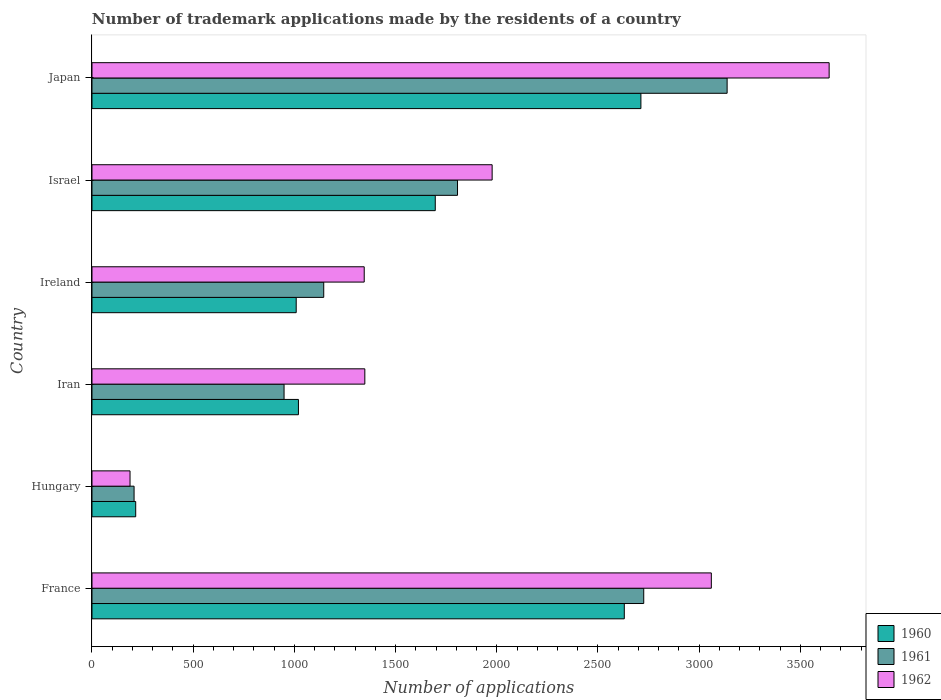Are the number of bars per tick equal to the number of legend labels?
Offer a very short reply. Yes. What is the number of trademark applications made by the residents in 1962 in Japan?
Give a very brief answer. 3642. Across all countries, what is the maximum number of trademark applications made by the residents in 1962?
Provide a succinct answer. 3642. Across all countries, what is the minimum number of trademark applications made by the residents in 1962?
Your answer should be compact. 188. In which country was the number of trademark applications made by the residents in 1960 minimum?
Offer a very short reply. Hungary. What is the total number of trademark applications made by the residents in 1961 in the graph?
Keep it short and to the point. 9972. What is the difference between the number of trademark applications made by the residents in 1960 in Hungary and that in Iran?
Offer a very short reply. -804. What is the difference between the number of trademark applications made by the residents in 1962 in Israel and the number of trademark applications made by the residents in 1961 in Ireland?
Your response must be concise. 832. What is the average number of trademark applications made by the residents in 1960 per country?
Your response must be concise. 1547.17. What is the ratio of the number of trademark applications made by the residents in 1962 in Iran to that in Israel?
Provide a succinct answer. 0.68. Is the number of trademark applications made by the residents in 1961 in France less than that in Japan?
Your answer should be compact. Yes. Is the difference between the number of trademark applications made by the residents in 1962 in Iran and Israel greater than the difference between the number of trademark applications made by the residents in 1961 in Iran and Israel?
Give a very brief answer. Yes. What is the difference between the highest and the second highest number of trademark applications made by the residents in 1961?
Ensure brevity in your answer.  412. What is the difference between the highest and the lowest number of trademark applications made by the residents in 1960?
Your response must be concise. 2496. Is the sum of the number of trademark applications made by the residents in 1962 in Israel and Japan greater than the maximum number of trademark applications made by the residents in 1961 across all countries?
Give a very brief answer. Yes. Is it the case that in every country, the sum of the number of trademark applications made by the residents in 1962 and number of trademark applications made by the residents in 1961 is greater than the number of trademark applications made by the residents in 1960?
Keep it short and to the point. Yes. How many bars are there?
Offer a terse response. 18. Are all the bars in the graph horizontal?
Offer a very short reply. Yes. Does the graph contain grids?
Offer a terse response. No. How many legend labels are there?
Make the answer very short. 3. How are the legend labels stacked?
Your answer should be compact. Vertical. What is the title of the graph?
Offer a terse response. Number of trademark applications made by the residents of a country. Does "1994" appear as one of the legend labels in the graph?
Offer a terse response. No. What is the label or title of the X-axis?
Give a very brief answer. Number of applications. What is the Number of applications in 1960 in France?
Your answer should be very brief. 2630. What is the Number of applications in 1961 in France?
Offer a terse response. 2726. What is the Number of applications of 1962 in France?
Your answer should be very brief. 3060. What is the Number of applications in 1960 in Hungary?
Provide a short and direct response. 216. What is the Number of applications of 1961 in Hungary?
Provide a short and direct response. 208. What is the Number of applications in 1962 in Hungary?
Offer a terse response. 188. What is the Number of applications in 1960 in Iran?
Keep it short and to the point. 1020. What is the Number of applications of 1961 in Iran?
Make the answer very short. 949. What is the Number of applications of 1962 in Iran?
Your answer should be compact. 1348. What is the Number of applications of 1960 in Ireland?
Provide a succinct answer. 1009. What is the Number of applications in 1961 in Ireland?
Give a very brief answer. 1145. What is the Number of applications of 1962 in Ireland?
Provide a succinct answer. 1345. What is the Number of applications of 1960 in Israel?
Your answer should be very brief. 1696. What is the Number of applications in 1961 in Israel?
Your answer should be compact. 1806. What is the Number of applications in 1962 in Israel?
Keep it short and to the point. 1977. What is the Number of applications in 1960 in Japan?
Your answer should be very brief. 2712. What is the Number of applications in 1961 in Japan?
Provide a succinct answer. 3138. What is the Number of applications in 1962 in Japan?
Make the answer very short. 3642. Across all countries, what is the maximum Number of applications of 1960?
Your response must be concise. 2712. Across all countries, what is the maximum Number of applications of 1961?
Provide a short and direct response. 3138. Across all countries, what is the maximum Number of applications in 1962?
Keep it short and to the point. 3642. Across all countries, what is the minimum Number of applications in 1960?
Make the answer very short. 216. Across all countries, what is the minimum Number of applications of 1961?
Keep it short and to the point. 208. Across all countries, what is the minimum Number of applications in 1962?
Make the answer very short. 188. What is the total Number of applications of 1960 in the graph?
Your response must be concise. 9283. What is the total Number of applications in 1961 in the graph?
Offer a terse response. 9972. What is the total Number of applications of 1962 in the graph?
Your response must be concise. 1.16e+04. What is the difference between the Number of applications in 1960 in France and that in Hungary?
Provide a short and direct response. 2414. What is the difference between the Number of applications in 1961 in France and that in Hungary?
Your answer should be very brief. 2518. What is the difference between the Number of applications in 1962 in France and that in Hungary?
Your answer should be very brief. 2872. What is the difference between the Number of applications of 1960 in France and that in Iran?
Your answer should be very brief. 1610. What is the difference between the Number of applications in 1961 in France and that in Iran?
Ensure brevity in your answer.  1777. What is the difference between the Number of applications of 1962 in France and that in Iran?
Your answer should be very brief. 1712. What is the difference between the Number of applications of 1960 in France and that in Ireland?
Provide a succinct answer. 1621. What is the difference between the Number of applications of 1961 in France and that in Ireland?
Offer a terse response. 1581. What is the difference between the Number of applications in 1962 in France and that in Ireland?
Your answer should be compact. 1715. What is the difference between the Number of applications of 1960 in France and that in Israel?
Ensure brevity in your answer.  934. What is the difference between the Number of applications of 1961 in France and that in Israel?
Keep it short and to the point. 920. What is the difference between the Number of applications of 1962 in France and that in Israel?
Make the answer very short. 1083. What is the difference between the Number of applications of 1960 in France and that in Japan?
Your response must be concise. -82. What is the difference between the Number of applications in 1961 in France and that in Japan?
Your response must be concise. -412. What is the difference between the Number of applications in 1962 in France and that in Japan?
Ensure brevity in your answer.  -582. What is the difference between the Number of applications of 1960 in Hungary and that in Iran?
Your answer should be compact. -804. What is the difference between the Number of applications of 1961 in Hungary and that in Iran?
Give a very brief answer. -741. What is the difference between the Number of applications in 1962 in Hungary and that in Iran?
Make the answer very short. -1160. What is the difference between the Number of applications in 1960 in Hungary and that in Ireland?
Offer a terse response. -793. What is the difference between the Number of applications in 1961 in Hungary and that in Ireland?
Your answer should be compact. -937. What is the difference between the Number of applications of 1962 in Hungary and that in Ireland?
Ensure brevity in your answer.  -1157. What is the difference between the Number of applications of 1960 in Hungary and that in Israel?
Make the answer very short. -1480. What is the difference between the Number of applications in 1961 in Hungary and that in Israel?
Keep it short and to the point. -1598. What is the difference between the Number of applications of 1962 in Hungary and that in Israel?
Keep it short and to the point. -1789. What is the difference between the Number of applications in 1960 in Hungary and that in Japan?
Ensure brevity in your answer.  -2496. What is the difference between the Number of applications of 1961 in Hungary and that in Japan?
Offer a very short reply. -2930. What is the difference between the Number of applications of 1962 in Hungary and that in Japan?
Provide a short and direct response. -3454. What is the difference between the Number of applications of 1961 in Iran and that in Ireland?
Provide a succinct answer. -196. What is the difference between the Number of applications in 1960 in Iran and that in Israel?
Ensure brevity in your answer.  -676. What is the difference between the Number of applications in 1961 in Iran and that in Israel?
Give a very brief answer. -857. What is the difference between the Number of applications of 1962 in Iran and that in Israel?
Offer a terse response. -629. What is the difference between the Number of applications in 1960 in Iran and that in Japan?
Give a very brief answer. -1692. What is the difference between the Number of applications in 1961 in Iran and that in Japan?
Offer a very short reply. -2189. What is the difference between the Number of applications in 1962 in Iran and that in Japan?
Keep it short and to the point. -2294. What is the difference between the Number of applications of 1960 in Ireland and that in Israel?
Give a very brief answer. -687. What is the difference between the Number of applications in 1961 in Ireland and that in Israel?
Keep it short and to the point. -661. What is the difference between the Number of applications in 1962 in Ireland and that in Israel?
Provide a short and direct response. -632. What is the difference between the Number of applications of 1960 in Ireland and that in Japan?
Provide a succinct answer. -1703. What is the difference between the Number of applications of 1961 in Ireland and that in Japan?
Offer a terse response. -1993. What is the difference between the Number of applications in 1962 in Ireland and that in Japan?
Offer a very short reply. -2297. What is the difference between the Number of applications in 1960 in Israel and that in Japan?
Your answer should be very brief. -1016. What is the difference between the Number of applications in 1961 in Israel and that in Japan?
Your answer should be very brief. -1332. What is the difference between the Number of applications in 1962 in Israel and that in Japan?
Make the answer very short. -1665. What is the difference between the Number of applications of 1960 in France and the Number of applications of 1961 in Hungary?
Keep it short and to the point. 2422. What is the difference between the Number of applications of 1960 in France and the Number of applications of 1962 in Hungary?
Your answer should be compact. 2442. What is the difference between the Number of applications of 1961 in France and the Number of applications of 1962 in Hungary?
Keep it short and to the point. 2538. What is the difference between the Number of applications in 1960 in France and the Number of applications in 1961 in Iran?
Provide a succinct answer. 1681. What is the difference between the Number of applications of 1960 in France and the Number of applications of 1962 in Iran?
Offer a very short reply. 1282. What is the difference between the Number of applications of 1961 in France and the Number of applications of 1962 in Iran?
Keep it short and to the point. 1378. What is the difference between the Number of applications of 1960 in France and the Number of applications of 1961 in Ireland?
Ensure brevity in your answer.  1485. What is the difference between the Number of applications in 1960 in France and the Number of applications in 1962 in Ireland?
Your answer should be very brief. 1285. What is the difference between the Number of applications in 1961 in France and the Number of applications in 1962 in Ireland?
Your answer should be compact. 1381. What is the difference between the Number of applications in 1960 in France and the Number of applications in 1961 in Israel?
Provide a short and direct response. 824. What is the difference between the Number of applications of 1960 in France and the Number of applications of 1962 in Israel?
Provide a succinct answer. 653. What is the difference between the Number of applications in 1961 in France and the Number of applications in 1962 in Israel?
Make the answer very short. 749. What is the difference between the Number of applications of 1960 in France and the Number of applications of 1961 in Japan?
Ensure brevity in your answer.  -508. What is the difference between the Number of applications in 1960 in France and the Number of applications in 1962 in Japan?
Your answer should be compact. -1012. What is the difference between the Number of applications of 1961 in France and the Number of applications of 1962 in Japan?
Give a very brief answer. -916. What is the difference between the Number of applications of 1960 in Hungary and the Number of applications of 1961 in Iran?
Offer a terse response. -733. What is the difference between the Number of applications of 1960 in Hungary and the Number of applications of 1962 in Iran?
Make the answer very short. -1132. What is the difference between the Number of applications of 1961 in Hungary and the Number of applications of 1962 in Iran?
Give a very brief answer. -1140. What is the difference between the Number of applications of 1960 in Hungary and the Number of applications of 1961 in Ireland?
Give a very brief answer. -929. What is the difference between the Number of applications in 1960 in Hungary and the Number of applications in 1962 in Ireland?
Offer a terse response. -1129. What is the difference between the Number of applications of 1961 in Hungary and the Number of applications of 1962 in Ireland?
Your response must be concise. -1137. What is the difference between the Number of applications in 1960 in Hungary and the Number of applications in 1961 in Israel?
Your answer should be compact. -1590. What is the difference between the Number of applications in 1960 in Hungary and the Number of applications in 1962 in Israel?
Offer a terse response. -1761. What is the difference between the Number of applications of 1961 in Hungary and the Number of applications of 1962 in Israel?
Offer a terse response. -1769. What is the difference between the Number of applications of 1960 in Hungary and the Number of applications of 1961 in Japan?
Give a very brief answer. -2922. What is the difference between the Number of applications of 1960 in Hungary and the Number of applications of 1962 in Japan?
Offer a very short reply. -3426. What is the difference between the Number of applications in 1961 in Hungary and the Number of applications in 1962 in Japan?
Ensure brevity in your answer.  -3434. What is the difference between the Number of applications in 1960 in Iran and the Number of applications in 1961 in Ireland?
Offer a very short reply. -125. What is the difference between the Number of applications of 1960 in Iran and the Number of applications of 1962 in Ireland?
Offer a very short reply. -325. What is the difference between the Number of applications of 1961 in Iran and the Number of applications of 1962 in Ireland?
Offer a terse response. -396. What is the difference between the Number of applications of 1960 in Iran and the Number of applications of 1961 in Israel?
Keep it short and to the point. -786. What is the difference between the Number of applications in 1960 in Iran and the Number of applications in 1962 in Israel?
Offer a terse response. -957. What is the difference between the Number of applications in 1961 in Iran and the Number of applications in 1962 in Israel?
Offer a terse response. -1028. What is the difference between the Number of applications of 1960 in Iran and the Number of applications of 1961 in Japan?
Offer a terse response. -2118. What is the difference between the Number of applications in 1960 in Iran and the Number of applications in 1962 in Japan?
Provide a short and direct response. -2622. What is the difference between the Number of applications in 1961 in Iran and the Number of applications in 1962 in Japan?
Offer a terse response. -2693. What is the difference between the Number of applications in 1960 in Ireland and the Number of applications in 1961 in Israel?
Your response must be concise. -797. What is the difference between the Number of applications of 1960 in Ireland and the Number of applications of 1962 in Israel?
Make the answer very short. -968. What is the difference between the Number of applications of 1961 in Ireland and the Number of applications of 1962 in Israel?
Ensure brevity in your answer.  -832. What is the difference between the Number of applications in 1960 in Ireland and the Number of applications in 1961 in Japan?
Keep it short and to the point. -2129. What is the difference between the Number of applications in 1960 in Ireland and the Number of applications in 1962 in Japan?
Your answer should be very brief. -2633. What is the difference between the Number of applications of 1961 in Ireland and the Number of applications of 1962 in Japan?
Offer a terse response. -2497. What is the difference between the Number of applications of 1960 in Israel and the Number of applications of 1961 in Japan?
Provide a short and direct response. -1442. What is the difference between the Number of applications of 1960 in Israel and the Number of applications of 1962 in Japan?
Your answer should be compact. -1946. What is the difference between the Number of applications in 1961 in Israel and the Number of applications in 1962 in Japan?
Your answer should be compact. -1836. What is the average Number of applications in 1960 per country?
Your response must be concise. 1547.17. What is the average Number of applications of 1961 per country?
Offer a terse response. 1662. What is the average Number of applications in 1962 per country?
Offer a terse response. 1926.67. What is the difference between the Number of applications in 1960 and Number of applications in 1961 in France?
Offer a very short reply. -96. What is the difference between the Number of applications of 1960 and Number of applications of 1962 in France?
Keep it short and to the point. -430. What is the difference between the Number of applications in 1961 and Number of applications in 1962 in France?
Your answer should be very brief. -334. What is the difference between the Number of applications of 1961 and Number of applications of 1962 in Hungary?
Your response must be concise. 20. What is the difference between the Number of applications in 1960 and Number of applications in 1962 in Iran?
Your answer should be compact. -328. What is the difference between the Number of applications in 1961 and Number of applications in 1962 in Iran?
Provide a succinct answer. -399. What is the difference between the Number of applications of 1960 and Number of applications of 1961 in Ireland?
Offer a very short reply. -136. What is the difference between the Number of applications of 1960 and Number of applications of 1962 in Ireland?
Keep it short and to the point. -336. What is the difference between the Number of applications in 1961 and Number of applications in 1962 in Ireland?
Give a very brief answer. -200. What is the difference between the Number of applications of 1960 and Number of applications of 1961 in Israel?
Give a very brief answer. -110. What is the difference between the Number of applications of 1960 and Number of applications of 1962 in Israel?
Your answer should be compact. -281. What is the difference between the Number of applications in 1961 and Number of applications in 1962 in Israel?
Your answer should be very brief. -171. What is the difference between the Number of applications in 1960 and Number of applications in 1961 in Japan?
Give a very brief answer. -426. What is the difference between the Number of applications in 1960 and Number of applications in 1962 in Japan?
Give a very brief answer. -930. What is the difference between the Number of applications in 1961 and Number of applications in 1962 in Japan?
Provide a succinct answer. -504. What is the ratio of the Number of applications of 1960 in France to that in Hungary?
Ensure brevity in your answer.  12.18. What is the ratio of the Number of applications in 1961 in France to that in Hungary?
Give a very brief answer. 13.11. What is the ratio of the Number of applications of 1962 in France to that in Hungary?
Provide a succinct answer. 16.28. What is the ratio of the Number of applications in 1960 in France to that in Iran?
Give a very brief answer. 2.58. What is the ratio of the Number of applications in 1961 in France to that in Iran?
Ensure brevity in your answer.  2.87. What is the ratio of the Number of applications in 1962 in France to that in Iran?
Provide a short and direct response. 2.27. What is the ratio of the Number of applications in 1960 in France to that in Ireland?
Your answer should be very brief. 2.61. What is the ratio of the Number of applications in 1961 in France to that in Ireland?
Your answer should be very brief. 2.38. What is the ratio of the Number of applications in 1962 in France to that in Ireland?
Your answer should be very brief. 2.28. What is the ratio of the Number of applications of 1960 in France to that in Israel?
Your response must be concise. 1.55. What is the ratio of the Number of applications of 1961 in France to that in Israel?
Your response must be concise. 1.51. What is the ratio of the Number of applications in 1962 in France to that in Israel?
Your answer should be very brief. 1.55. What is the ratio of the Number of applications in 1960 in France to that in Japan?
Offer a very short reply. 0.97. What is the ratio of the Number of applications in 1961 in France to that in Japan?
Offer a very short reply. 0.87. What is the ratio of the Number of applications in 1962 in France to that in Japan?
Provide a succinct answer. 0.84. What is the ratio of the Number of applications of 1960 in Hungary to that in Iran?
Ensure brevity in your answer.  0.21. What is the ratio of the Number of applications in 1961 in Hungary to that in Iran?
Keep it short and to the point. 0.22. What is the ratio of the Number of applications of 1962 in Hungary to that in Iran?
Your answer should be very brief. 0.14. What is the ratio of the Number of applications in 1960 in Hungary to that in Ireland?
Your answer should be compact. 0.21. What is the ratio of the Number of applications of 1961 in Hungary to that in Ireland?
Provide a succinct answer. 0.18. What is the ratio of the Number of applications in 1962 in Hungary to that in Ireland?
Make the answer very short. 0.14. What is the ratio of the Number of applications in 1960 in Hungary to that in Israel?
Provide a short and direct response. 0.13. What is the ratio of the Number of applications in 1961 in Hungary to that in Israel?
Your response must be concise. 0.12. What is the ratio of the Number of applications in 1962 in Hungary to that in Israel?
Give a very brief answer. 0.1. What is the ratio of the Number of applications of 1960 in Hungary to that in Japan?
Provide a short and direct response. 0.08. What is the ratio of the Number of applications in 1961 in Hungary to that in Japan?
Your answer should be compact. 0.07. What is the ratio of the Number of applications of 1962 in Hungary to that in Japan?
Ensure brevity in your answer.  0.05. What is the ratio of the Number of applications of 1960 in Iran to that in Ireland?
Make the answer very short. 1.01. What is the ratio of the Number of applications of 1961 in Iran to that in Ireland?
Make the answer very short. 0.83. What is the ratio of the Number of applications in 1960 in Iran to that in Israel?
Your answer should be compact. 0.6. What is the ratio of the Number of applications of 1961 in Iran to that in Israel?
Provide a succinct answer. 0.53. What is the ratio of the Number of applications in 1962 in Iran to that in Israel?
Provide a succinct answer. 0.68. What is the ratio of the Number of applications in 1960 in Iran to that in Japan?
Keep it short and to the point. 0.38. What is the ratio of the Number of applications in 1961 in Iran to that in Japan?
Provide a succinct answer. 0.3. What is the ratio of the Number of applications in 1962 in Iran to that in Japan?
Keep it short and to the point. 0.37. What is the ratio of the Number of applications in 1960 in Ireland to that in Israel?
Your answer should be very brief. 0.59. What is the ratio of the Number of applications in 1961 in Ireland to that in Israel?
Provide a succinct answer. 0.63. What is the ratio of the Number of applications in 1962 in Ireland to that in Israel?
Your response must be concise. 0.68. What is the ratio of the Number of applications of 1960 in Ireland to that in Japan?
Your answer should be very brief. 0.37. What is the ratio of the Number of applications of 1961 in Ireland to that in Japan?
Offer a very short reply. 0.36. What is the ratio of the Number of applications of 1962 in Ireland to that in Japan?
Ensure brevity in your answer.  0.37. What is the ratio of the Number of applications of 1960 in Israel to that in Japan?
Give a very brief answer. 0.63. What is the ratio of the Number of applications in 1961 in Israel to that in Japan?
Keep it short and to the point. 0.58. What is the ratio of the Number of applications of 1962 in Israel to that in Japan?
Provide a succinct answer. 0.54. What is the difference between the highest and the second highest Number of applications in 1960?
Offer a terse response. 82. What is the difference between the highest and the second highest Number of applications of 1961?
Provide a short and direct response. 412. What is the difference between the highest and the second highest Number of applications in 1962?
Make the answer very short. 582. What is the difference between the highest and the lowest Number of applications of 1960?
Offer a terse response. 2496. What is the difference between the highest and the lowest Number of applications in 1961?
Keep it short and to the point. 2930. What is the difference between the highest and the lowest Number of applications in 1962?
Make the answer very short. 3454. 